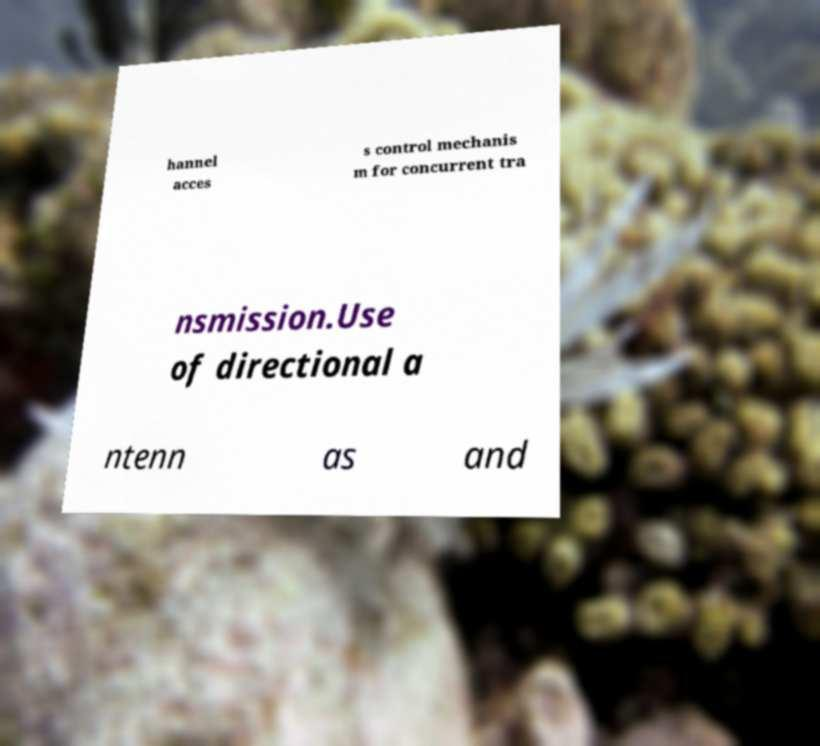Could you assist in decoding the text presented in this image and type it out clearly? hannel acces s control mechanis m for concurrent tra nsmission.Use of directional a ntenn as and 